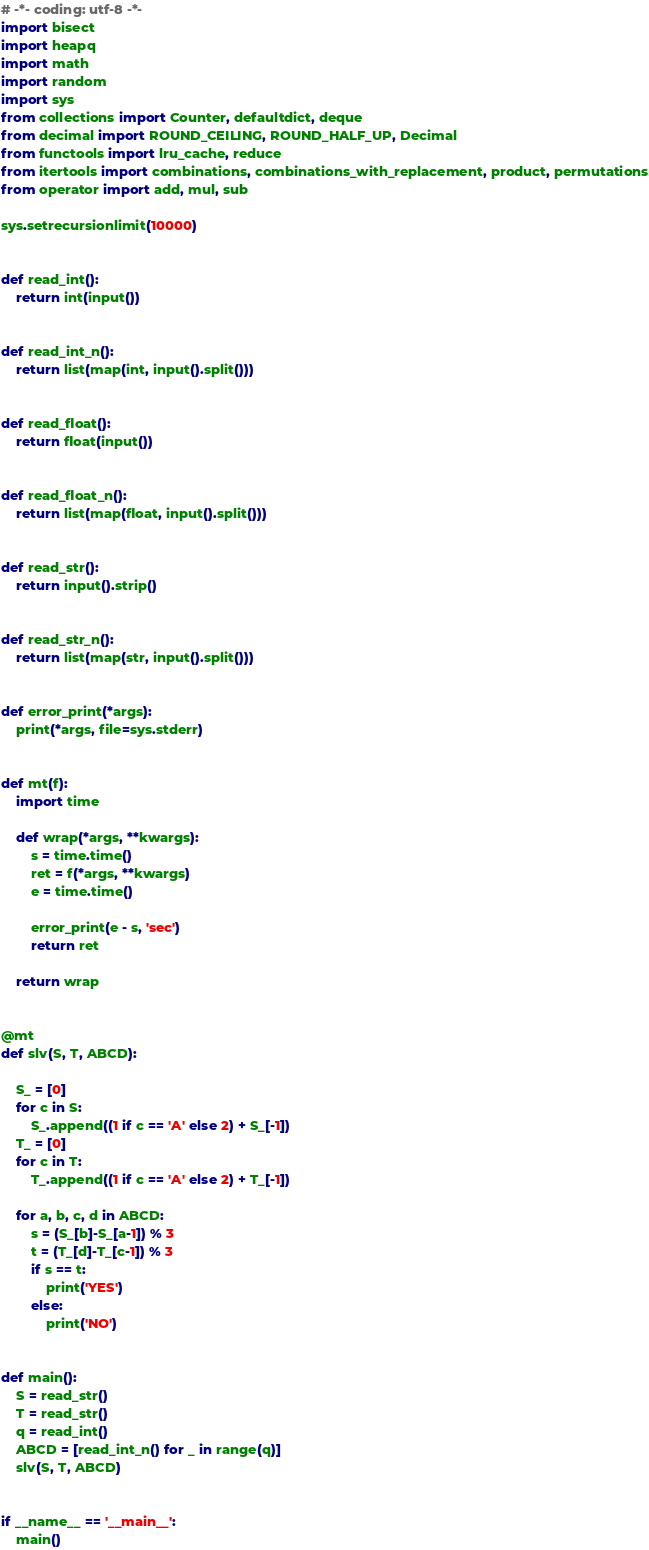<code> <loc_0><loc_0><loc_500><loc_500><_Python_># -*- coding: utf-8 -*-
import bisect
import heapq
import math
import random
import sys
from collections import Counter, defaultdict, deque
from decimal import ROUND_CEILING, ROUND_HALF_UP, Decimal
from functools import lru_cache, reduce
from itertools import combinations, combinations_with_replacement, product, permutations
from operator import add, mul, sub

sys.setrecursionlimit(10000)


def read_int():
    return int(input())


def read_int_n():
    return list(map(int, input().split()))


def read_float():
    return float(input())


def read_float_n():
    return list(map(float, input().split()))


def read_str():
    return input().strip()


def read_str_n():
    return list(map(str, input().split()))


def error_print(*args):
    print(*args, file=sys.stderr)


def mt(f):
    import time

    def wrap(*args, **kwargs):
        s = time.time()
        ret = f(*args, **kwargs)
        e = time.time()

        error_print(e - s, 'sec')
        return ret

    return wrap


@mt
def slv(S, T, ABCD):

    S_ = [0]
    for c in S:
        S_.append((1 if c == 'A' else 2) + S_[-1])
    T_ = [0]
    for c in T:
        T_.append((1 if c == 'A' else 2) + T_[-1])

    for a, b, c, d in ABCD:
        s = (S_[b]-S_[a-1]) % 3
        t = (T_[d]-T_[c-1]) % 3
        if s == t:
            print('YES')
        else:
            print('NO')


def main():
    S = read_str()
    T = read_str()
    q = read_int()
    ABCD = [read_int_n() for _ in range(q)]
    slv(S, T, ABCD)


if __name__ == '__main__':
    main()
</code> 